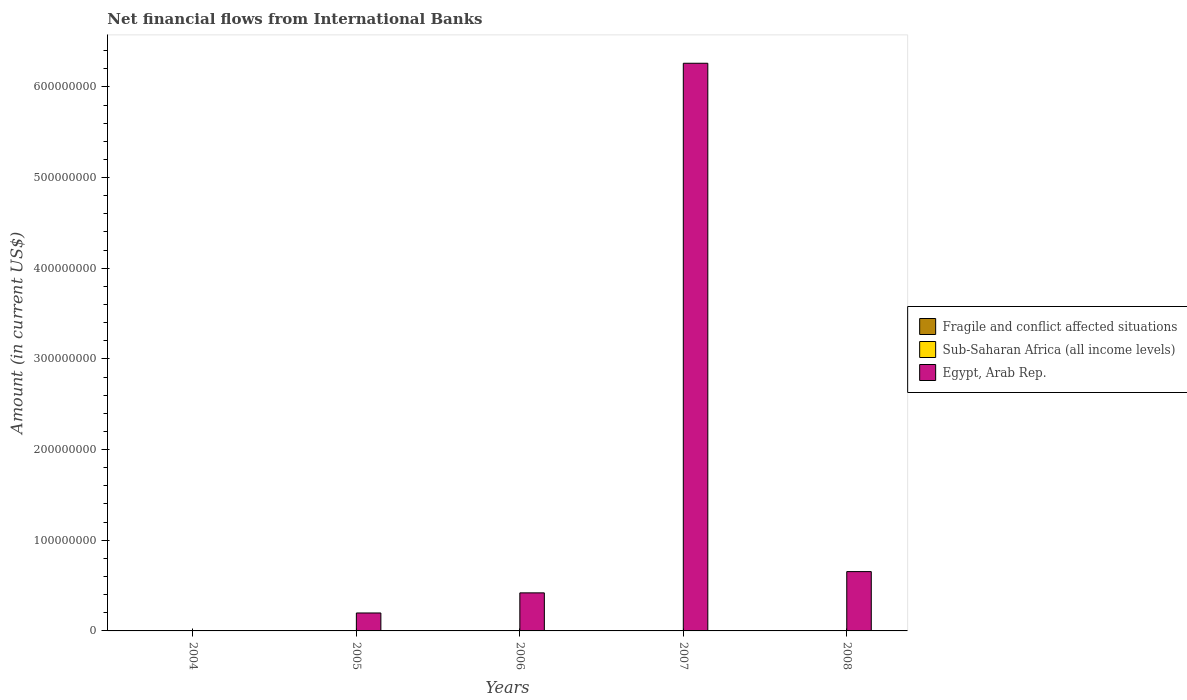How many different coloured bars are there?
Offer a very short reply. 1. Are the number of bars per tick equal to the number of legend labels?
Offer a terse response. No. How many bars are there on the 4th tick from the left?
Your answer should be compact. 1. In how many cases, is the number of bars for a given year not equal to the number of legend labels?
Give a very brief answer. 5. What is the net financial aid flows in Fragile and conflict affected situations in 2005?
Your response must be concise. 0. Across all years, what is the maximum net financial aid flows in Egypt, Arab Rep.?
Your response must be concise. 6.26e+08. What is the total net financial aid flows in Egypt, Arab Rep. in the graph?
Keep it short and to the point. 7.53e+08. What is the difference between the net financial aid flows in Egypt, Arab Rep. in 2007 and that in 2008?
Give a very brief answer. 5.61e+08. What is the difference between the net financial aid flows in Egypt, Arab Rep. in 2005 and the net financial aid flows in Sub-Saharan Africa (all income levels) in 2004?
Make the answer very short. 1.98e+07. What is the average net financial aid flows in Egypt, Arab Rep. per year?
Ensure brevity in your answer.  1.51e+08. In how many years, is the net financial aid flows in Fragile and conflict affected situations greater than 300000000 US$?
Provide a short and direct response. 0. What is the ratio of the net financial aid flows in Egypt, Arab Rep. in 2006 to that in 2008?
Your answer should be very brief. 0.64. What is the difference between the highest and the second highest net financial aid flows in Egypt, Arab Rep.?
Your answer should be very brief. 5.61e+08. What is the difference between the highest and the lowest net financial aid flows in Egypt, Arab Rep.?
Your answer should be compact. 6.26e+08. In how many years, is the net financial aid flows in Egypt, Arab Rep. greater than the average net financial aid flows in Egypt, Arab Rep. taken over all years?
Keep it short and to the point. 1. Is the sum of the net financial aid flows in Egypt, Arab Rep. in 2005 and 2006 greater than the maximum net financial aid flows in Sub-Saharan Africa (all income levels) across all years?
Make the answer very short. Yes. Are all the bars in the graph horizontal?
Provide a short and direct response. No. Does the graph contain grids?
Your answer should be compact. No. How are the legend labels stacked?
Your answer should be very brief. Vertical. What is the title of the graph?
Your response must be concise. Net financial flows from International Banks. Does "Turkmenistan" appear as one of the legend labels in the graph?
Make the answer very short. No. What is the label or title of the X-axis?
Provide a short and direct response. Years. What is the label or title of the Y-axis?
Provide a succinct answer. Amount (in current US$). What is the Amount (in current US$) in Fragile and conflict affected situations in 2005?
Offer a very short reply. 0. What is the Amount (in current US$) in Egypt, Arab Rep. in 2005?
Make the answer very short. 1.98e+07. What is the Amount (in current US$) of Egypt, Arab Rep. in 2006?
Make the answer very short. 4.20e+07. What is the Amount (in current US$) in Fragile and conflict affected situations in 2007?
Provide a succinct answer. 0. What is the Amount (in current US$) in Sub-Saharan Africa (all income levels) in 2007?
Offer a very short reply. 0. What is the Amount (in current US$) of Egypt, Arab Rep. in 2007?
Offer a terse response. 6.26e+08. What is the Amount (in current US$) in Sub-Saharan Africa (all income levels) in 2008?
Offer a very short reply. 0. What is the Amount (in current US$) in Egypt, Arab Rep. in 2008?
Provide a short and direct response. 6.54e+07. Across all years, what is the maximum Amount (in current US$) of Egypt, Arab Rep.?
Keep it short and to the point. 6.26e+08. Across all years, what is the minimum Amount (in current US$) of Egypt, Arab Rep.?
Make the answer very short. 0. What is the total Amount (in current US$) of Egypt, Arab Rep. in the graph?
Make the answer very short. 7.53e+08. What is the difference between the Amount (in current US$) of Egypt, Arab Rep. in 2005 and that in 2006?
Offer a very short reply. -2.22e+07. What is the difference between the Amount (in current US$) in Egypt, Arab Rep. in 2005 and that in 2007?
Make the answer very short. -6.06e+08. What is the difference between the Amount (in current US$) in Egypt, Arab Rep. in 2005 and that in 2008?
Provide a succinct answer. -4.56e+07. What is the difference between the Amount (in current US$) in Egypt, Arab Rep. in 2006 and that in 2007?
Ensure brevity in your answer.  -5.84e+08. What is the difference between the Amount (in current US$) in Egypt, Arab Rep. in 2006 and that in 2008?
Make the answer very short. -2.34e+07. What is the difference between the Amount (in current US$) in Egypt, Arab Rep. in 2007 and that in 2008?
Provide a succinct answer. 5.61e+08. What is the average Amount (in current US$) in Fragile and conflict affected situations per year?
Give a very brief answer. 0. What is the average Amount (in current US$) in Sub-Saharan Africa (all income levels) per year?
Give a very brief answer. 0. What is the average Amount (in current US$) in Egypt, Arab Rep. per year?
Ensure brevity in your answer.  1.51e+08. What is the ratio of the Amount (in current US$) in Egypt, Arab Rep. in 2005 to that in 2006?
Offer a very short reply. 0.47. What is the ratio of the Amount (in current US$) in Egypt, Arab Rep. in 2005 to that in 2007?
Offer a very short reply. 0.03. What is the ratio of the Amount (in current US$) in Egypt, Arab Rep. in 2005 to that in 2008?
Provide a succinct answer. 0.3. What is the ratio of the Amount (in current US$) of Egypt, Arab Rep. in 2006 to that in 2007?
Your answer should be compact. 0.07. What is the ratio of the Amount (in current US$) of Egypt, Arab Rep. in 2006 to that in 2008?
Your answer should be very brief. 0.64. What is the ratio of the Amount (in current US$) in Egypt, Arab Rep. in 2007 to that in 2008?
Your answer should be compact. 9.57. What is the difference between the highest and the second highest Amount (in current US$) in Egypt, Arab Rep.?
Your answer should be very brief. 5.61e+08. What is the difference between the highest and the lowest Amount (in current US$) of Egypt, Arab Rep.?
Give a very brief answer. 6.26e+08. 